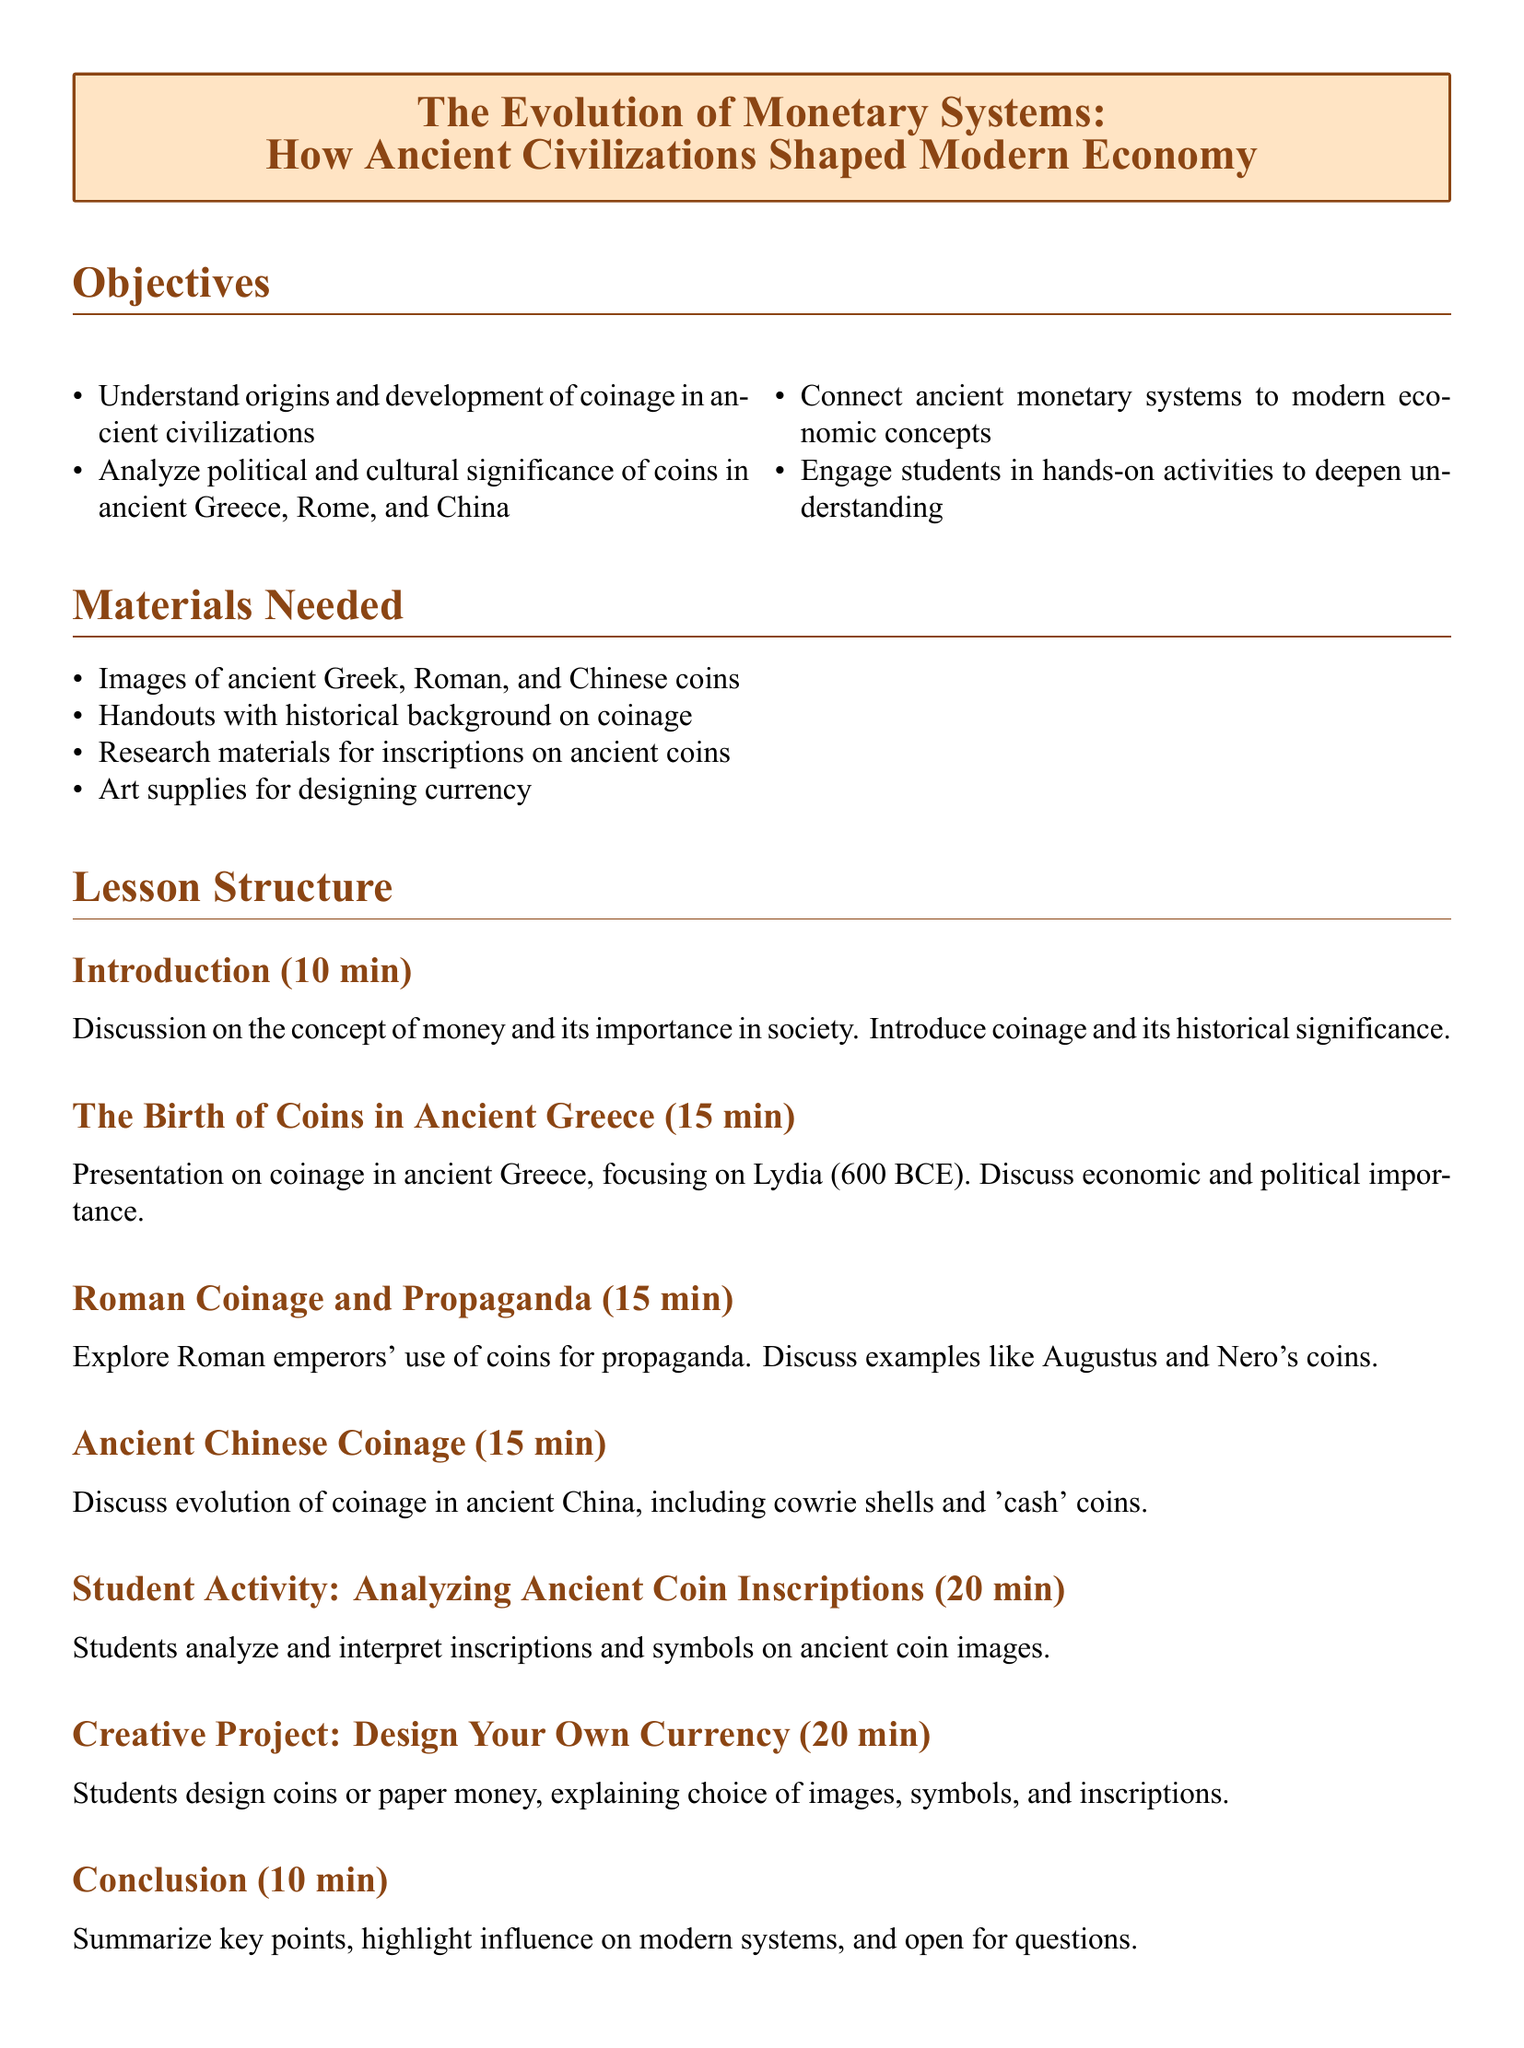What is the main topic of the lesson plan? The main topic is the evolution of monetary systems and how ancient civilizations shaped the modern economy.
Answer: The Evolution of Monetary Systems What civilization is highlighted for the birth of coins? The document mentions Lydia as significant for the birth of coins around 600 BCE.
Answer: Lydia How long is the student activity analyzing ancient coin inscriptions? The duration for the student activity is specified in the document.
Answer: 20 min What item is included in the materials needed for the lesson? The document lists images of ancient coins as one of the materials.
Answer: Images of ancient Greek, Roman, and Chinese coins Name one book recommended as an additional resource. The document provides a list of books, one of which is 'Money: The Unauthorized Biography' by Felix Martin.
Answer: Money: The Unauthorized Biography What is the total time allocated for the introduction section? The introduction section's duration is indicated in the lesson structure.
Answer: 10 min Which activity involves designing currency? The creative project focuses on the design of coins or paper money with explanations of symbols and inscriptions.
Answer: Design Your Own Currency Who is mentioned in relation to Roman coinage and propaganda? The document specifically references Augustus and Nero concerning Roman coinage.
Answer: Augustus and Nero What is one of the objectives of the lesson? The lesson has specific objectives, one of which is to connect ancient monetary systems to modern economic concepts.
Answer: Connect ancient monetary systems to modern economic concepts 